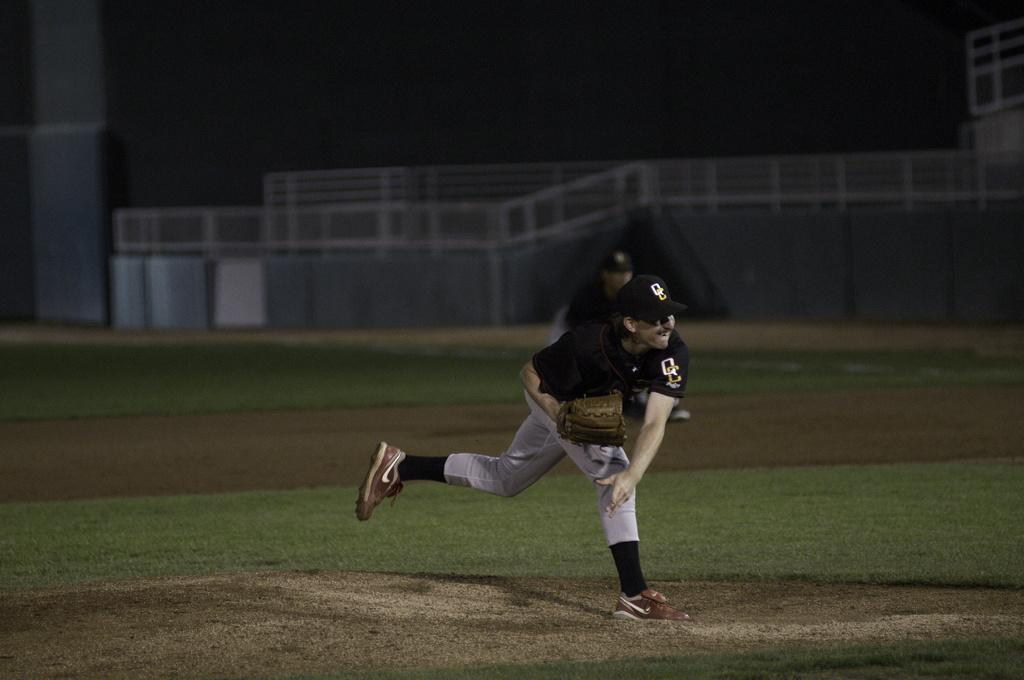What is the person in the image wearing on their hands and head? The person is wearing gloves and a cap in the image. What activity is the person engaged in? The person is playing baseball. Can you describe the presence of another person in the image? There is another person in the background of the image. What type of terrain is visible in the image? The ground is covered with grassland. What architectural feature can be seen in the background of the image? There is a wall with railings in the background of the image. Where is the nest of the bird located in the image? There is no bird or nest present in the image. What type of system is being used by the person to play baseball in the image? The image does not provide information about any specific system being used by the person to play baseball. 